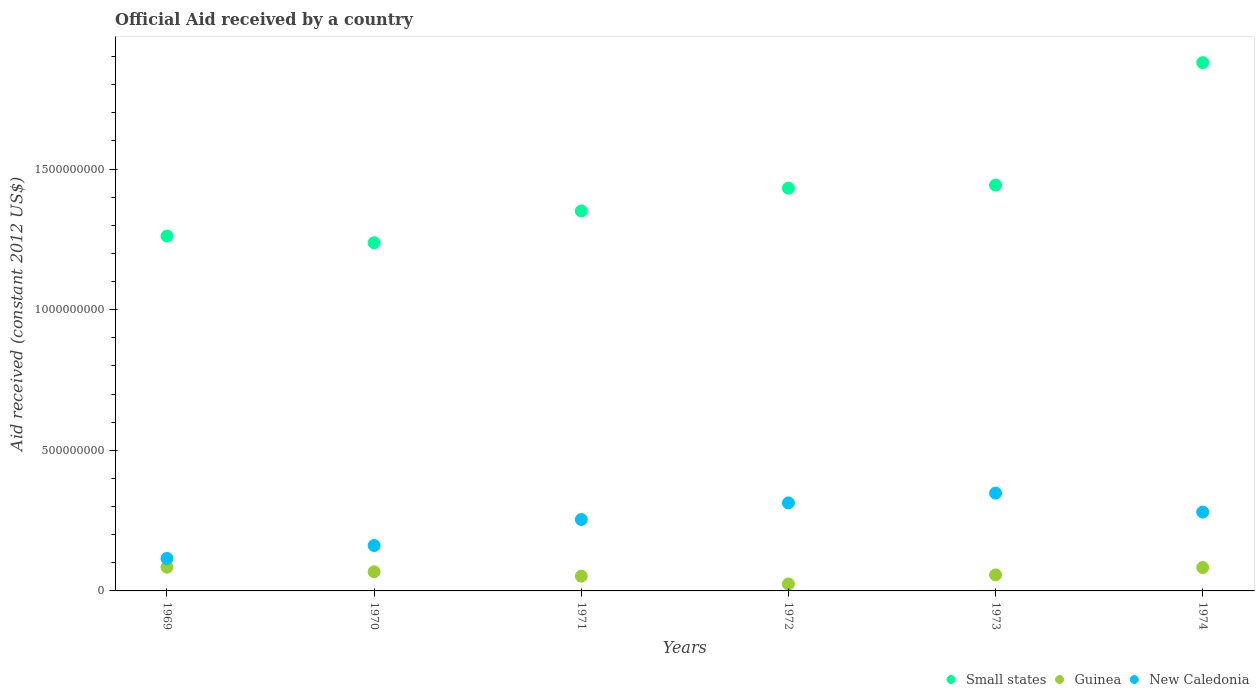What is the net official aid received in Guinea in 1969?
Provide a succinct answer. 8.44e+07. Across all years, what is the maximum net official aid received in Guinea?
Make the answer very short. 8.44e+07. Across all years, what is the minimum net official aid received in Small states?
Offer a very short reply. 1.24e+09. In which year was the net official aid received in Small states maximum?
Give a very brief answer. 1974. In which year was the net official aid received in Guinea minimum?
Your response must be concise. 1972. What is the total net official aid received in Guinea in the graph?
Provide a succinct answer. 3.70e+08. What is the difference between the net official aid received in New Caledonia in 1971 and that in 1973?
Provide a succinct answer. -9.39e+07. What is the difference between the net official aid received in Guinea in 1969 and the net official aid received in Small states in 1971?
Ensure brevity in your answer.  -1.27e+09. What is the average net official aid received in Guinea per year?
Make the answer very short. 6.16e+07. In the year 1972, what is the difference between the net official aid received in Guinea and net official aid received in New Caledonia?
Keep it short and to the point. -2.88e+08. What is the ratio of the net official aid received in New Caledonia in 1972 to that in 1973?
Give a very brief answer. 0.9. Is the net official aid received in Small states in 1970 less than that in 1972?
Make the answer very short. Yes. Is the difference between the net official aid received in Guinea in 1969 and 1973 greater than the difference between the net official aid received in New Caledonia in 1969 and 1973?
Your answer should be compact. Yes. What is the difference between the highest and the second highest net official aid received in Small states?
Offer a very short reply. 4.35e+08. What is the difference between the highest and the lowest net official aid received in Small states?
Provide a short and direct response. 6.40e+08. In how many years, is the net official aid received in Small states greater than the average net official aid received in Small states taken over all years?
Your answer should be compact. 2. Is the sum of the net official aid received in Guinea in 1970 and 1972 greater than the maximum net official aid received in Small states across all years?
Offer a very short reply. No. Is it the case that in every year, the sum of the net official aid received in Guinea and net official aid received in New Caledonia  is greater than the net official aid received in Small states?
Your response must be concise. No. Is the net official aid received in New Caledonia strictly less than the net official aid received in Small states over the years?
Your answer should be very brief. Yes. How many dotlines are there?
Ensure brevity in your answer.  3. How many years are there in the graph?
Your answer should be compact. 6. Does the graph contain any zero values?
Provide a succinct answer. No. What is the title of the graph?
Provide a succinct answer. Official Aid received by a country. What is the label or title of the X-axis?
Provide a short and direct response. Years. What is the label or title of the Y-axis?
Give a very brief answer. Aid received (constant 2012 US$). What is the Aid received (constant 2012 US$) of Small states in 1969?
Offer a very short reply. 1.26e+09. What is the Aid received (constant 2012 US$) in Guinea in 1969?
Your answer should be very brief. 8.44e+07. What is the Aid received (constant 2012 US$) in New Caledonia in 1969?
Your response must be concise. 1.15e+08. What is the Aid received (constant 2012 US$) in Small states in 1970?
Ensure brevity in your answer.  1.24e+09. What is the Aid received (constant 2012 US$) in Guinea in 1970?
Offer a terse response. 6.80e+07. What is the Aid received (constant 2012 US$) in New Caledonia in 1970?
Offer a very short reply. 1.61e+08. What is the Aid received (constant 2012 US$) of Small states in 1971?
Your response must be concise. 1.35e+09. What is the Aid received (constant 2012 US$) in Guinea in 1971?
Your answer should be very brief. 5.26e+07. What is the Aid received (constant 2012 US$) of New Caledonia in 1971?
Provide a succinct answer. 2.54e+08. What is the Aid received (constant 2012 US$) of Small states in 1972?
Ensure brevity in your answer.  1.43e+09. What is the Aid received (constant 2012 US$) in Guinea in 1972?
Your answer should be very brief. 2.47e+07. What is the Aid received (constant 2012 US$) in New Caledonia in 1972?
Ensure brevity in your answer.  3.13e+08. What is the Aid received (constant 2012 US$) in Small states in 1973?
Your answer should be very brief. 1.44e+09. What is the Aid received (constant 2012 US$) of Guinea in 1973?
Offer a terse response. 5.69e+07. What is the Aid received (constant 2012 US$) of New Caledonia in 1973?
Your answer should be very brief. 3.48e+08. What is the Aid received (constant 2012 US$) in Small states in 1974?
Your answer should be very brief. 1.88e+09. What is the Aid received (constant 2012 US$) in Guinea in 1974?
Make the answer very short. 8.30e+07. What is the Aid received (constant 2012 US$) in New Caledonia in 1974?
Your answer should be compact. 2.80e+08. Across all years, what is the maximum Aid received (constant 2012 US$) in Small states?
Your response must be concise. 1.88e+09. Across all years, what is the maximum Aid received (constant 2012 US$) in Guinea?
Make the answer very short. 8.44e+07. Across all years, what is the maximum Aid received (constant 2012 US$) of New Caledonia?
Give a very brief answer. 3.48e+08. Across all years, what is the minimum Aid received (constant 2012 US$) of Small states?
Make the answer very short. 1.24e+09. Across all years, what is the minimum Aid received (constant 2012 US$) of Guinea?
Keep it short and to the point. 2.47e+07. Across all years, what is the minimum Aid received (constant 2012 US$) of New Caledonia?
Your answer should be very brief. 1.15e+08. What is the total Aid received (constant 2012 US$) in Small states in the graph?
Your response must be concise. 8.60e+09. What is the total Aid received (constant 2012 US$) of Guinea in the graph?
Your answer should be compact. 3.70e+08. What is the total Aid received (constant 2012 US$) in New Caledonia in the graph?
Offer a terse response. 1.47e+09. What is the difference between the Aid received (constant 2012 US$) in Small states in 1969 and that in 1970?
Ensure brevity in your answer.  2.37e+07. What is the difference between the Aid received (constant 2012 US$) of Guinea in 1969 and that in 1970?
Keep it short and to the point. 1.64e+07. What is the difference between the Aid received (constant 2012 US$) in New Caledonia in 1969 and that in 1970?
Offer a terse response. -4.61e+07. What is the difference between the Aid received (constant 2012 US$) in Small states in 1969 and that in 1971?
Your answer should be compact. -8.92e+07. What is the difference between the Aid received (constant 2012 US$) of Guinea in 1969 and that in 1971?
Provide a short and direct response. 3.18e+07. What is the difference between the Aid received (constant 2012 US$) of New Caledonia in 1969 and that in 1971?
Offer a very short reply. -1.38e+08. What is the difference between the Aid received (constant 2012 US$) of Small states in 1969 and that in 1972?
Your answer should be very brief. -1.70e+08. What is the difference between the Aid received (constant 2012 US$) of Guinea in 1969 and that in 1972?
Ensure brevity in your answer.  5.97e+07. What is the difference between the Aid received (constant 2012 US$) of New Caledonia in 1969 and that in 1972?
Your answer should be very brief. -1.98e+08. What is the difference between the Aid received (constant 2012 US$) of Small states in 1969 and that in 1973?
Make the answer very short. -1.81e+08. What is the difference between the Aid received (constant 2012 US$) of Guinea in 1969 and that in 1973?
Keep it short and to the point. 2.75e+07. What is the difference between the Aid received (constant 2012 US$) in New Caledonia in 1969 and that in 1973?
Provide a succinct answer. -2.32e+08. What is the difference between the Aid received (constant 2012 US$) of Small states in 1969 and that in 1974?
Provide a short and direct response. -6.17e+08. What is the difference between the Aid received (constant 2012 US$) in Guinea in 1969 and that in 1974?
Make the answer very short. 1.37e+06. What is the difference between the Aid received (constant 2012 US$) of New Caledonia in 1969 and that in 1974?
Your answer should be compact. -1.65e+08. What is the difference between the Aid received (constant 2012 US$) of Small states in 1970 and that in 1971?
Provide a short and direct response. -1.13e+08. What is the difference between the Aid received (constant 2012 US$) in Guinea in 1970 and that in 1971?
Make the answer very short. 1.54e+07. What is the difference between the Aid received (constant 2012 US$) of New Caledonia in 1970 and that in 1971?
Ensure brevity in your answer.  -9.24e+07. What is the difference between the Aid received (constant 2012 US$) of Small states in 1970 and that in 1972?
Offer a terse response. -1.94e+08. What is the difference between the Aid received (constant 2012 US$) of Guinea in 1970 and that in 1972?
Keep it short and to the point. 4.33e+07. What is the difference between the Aid received (constant 2012 US$) of New Caledonia in 1970 and that in 1972?
Offer a terse response. -1.52e+08. What is the difference between the Aid received (constant 2012 US$) in Small states in 1970 and that in 1973?
Make the answer very short. -2.05e+08. What is the difference between the Aid received (constant 2012 US$) of Guinea in 1970 and that in 1973?
Your answer should be very brief. 1.11e+07. What is the difference between the Aid received (constant 2012 US$) in New Caledonia in 1970 and that in 1973?
Make the answer very short. -1.86e+08. What is the difference between the Aid received (constant 2012 US$) of Small states in 1970 and that in 1974?
Your answer should be very brief. -6.40e+08. What is the difference between the Aid received (constant 2012 US$) in Guinea in 1970 and that in 1974?
Offer a terse response. -1.50e+07. What is the difference between the Aid received (constant 2012 US$) of New Caledonia in 1970 and that in 1974?
Make the answer very short. -1.19e+08. What is the difference between the Aid received (constant 2012 US$) of Small states in 1971 and that in 1972?
Your answer should be very brief. -8.12e+07. What is the difference between the Aid received (constant 2012 US$) in Guinea in 1971 and that in 1972?
Offer a terse response. 2.79e+07. What is the difference between the Aid received (constant 2012 US$) of New Caledonia in 1971 and that in 1972?
Make the answer very short. -5.91e+07. What is the difference between the Aid received (constant 2012 US$) of Small states in 1971 and that in 1973?
Your response must be concise. -9.20e+07. What is the difference between the Aid received (constant 2012 US$) in Guinea in 1971 and that in 1973?
Keep it short and to the point. -4.32e+06. What is the difference between the Aid received (constant 2012 US$) in New Caledonia in 1971 and that in 1973?
Offer a terse response. -9.39e+07. What is the difference between the Aid received (constant 2012 US$) of Small states in 1971 and that in 1974?
Offer a terse response. -5.27e+08. What is the difference between the Aid received (constant 2012 US$) of Guinea in 1971 and that in 1974?
Your response must be concise. -3.05e+07. What is the difference between the Aid received (constant 2012 US$) of New Caledonia in 1971 and that in 1974?
Provide a short and direct response. -2.65e+07. What is the difference between the Aid received (constant 2012 US$) in Small states in 1972 and that in 1973?
Make the answer very short. -1.08e+07. What is the difference between the Aid received (constant 2012 US$) in Guinea in 1972 and that in 1973?
Provide a succinct answer. -3.22e+07. What is the difference between the Aid received (constant 2012 US$) of New Caledonia in 1972 and that in 1973?
Provide a short and direct response. -3.47e+07. What is the difference between the Aid received (constant 2012 US$) of Small states in 1972 and that in 1974?
Your response must be concise. -4.46e+08. What is the difference between the Aid received (constant 2012 US$) in Guinea in 1972 and that in 1974?
Offer a terse response. -5.83e+07. What is the difference between the Aid received (constant 2012 US$) of New Caledonia in 1972 and that in 1974?
Give a very brief answer. 3.26e+07. What is the difference between the Aid received (constant 2012 US$) of Small states in 1973 and that in 1974?
Provide a short and direct response. -4.35e+08. What is the difference between the Aid received (constant 2012 US$) of Guinea in 1973 and that in 1974?
Make the answer very short. -2.61e+07. What is the difference between the Aid received (constant 2012 US$) of New Caledonia in 1973 and that in 1974?
Your answer should be compact. 6.73e+07. What is the difference between the Aid received (constant 2012 US$) of Small states in 1969 and the Aid received (constant 2012 US$) of Guinea in 1970?
Your response must be concise. 1.19e+09. What is the difference between the Aid received (constant 2012 US$) of Small states in 1969 and the Aid received (constant 2012 US$) of New Caledonia in 1970?
Give a very brief answer. 1.10e+09. What is the difference between the Aid received (constant 2012 US$) of Guinea in 1969 and the Aid received (constant 2012 US$) of New Caledonia in 1970?
Provide a short and direct response. -7.70e+07. What is the difference between the Aid received (constant 2012 US$) in Small states in 1969 and the Aid received (constant 2012 US$) in Guinea in 1971?
Your answer should be very brief. 1.21e+09. What is the difference between the Aid received (constant 2012 US$) in Small states in 1969 and the Aid received (constant 2012 US$) in New Caledonia in 1971?
Offer a terse response. 1.01e+09. What is the difference between the Aid received (constant 2012 US$) of Guinea in 1969 and the Aid received (constant 2012 US$) of New Caledonia in 1971?
Ensure brevity in your answer.  -1.69e+08. What is the difference between the Aid received (constant 2012 US$) of Small states in 1969 and the Aid received (constant 2012 US$) of Guinea in 1972?
Offer a very short reply. 1.24e+09. What is the difference between the Aid received (constant 2012 US$) of Small states in 1969 and the Aid received (constant 2012 US$) of New Caledonia in 1972?
Your answer should be very brief. 9.48e+08. What is the difference between the Aid received (constant 2012 US$) in Guinea in 1969 and the Aid received (constant 2012 US$) in New Caledonia in 1972?
Ensure brevity in your answer.  -2.29e+08. What is the difference between the Aid received (constant 2012 US$) of Small states in 1969 and the Aid received (constant 2012 US$) of Guinea in 1973?
Keep it short and to the point. 1.20e+09. What is the difference between the Aid received (constant 2012 US$) of Small states in 1969 and the Aid received (constant 2012 US$) of New Caledonia in 1973?
Your response must be concise. 9.14e+08. What is the difference between the Aid received (constant 2012 US$) of Guinea in 1969 and the Aid received (constant 2012 US$) of New Caledonia in 1973?
Give a very brief answer. -2.63e+08. What is the difference between the Aid received (constant 2012 US$) in Small states in 1969 and the Aid received (constant 2012 US$) in Guinea in 1974?
Give a very brief answer. 1.18e+09. What is the difference between the Aid received (constant 2012 US$) of Small states in 1969 and the Aid received (constant 2012 US$) of New Caledonia in 1974?
Give a very brief answer. 9.81e+08. What is the difference between the Aid received (constant 2012 US$) of Guinea in 1969 and the Aid received (constant 2012 US$) of New Caledonia in 1974?
Keep it short and to the point. -1.96e+08. What is the difference between the Aid received (constant 2012 US$) of Small states in 1970 and the Aid received (constant 2012 US$) of Guinea in 1971?
Your answer should be very brief. 1.19e+09. What is the difference between the Aid received (constant 2012 US$) in Small states in 1970 and the Aid received (constant 2012 US$) in New Caledonia in 1971?
Make the answer very short. 9.84e+08. What is the difference between the Aid received (constant 2012 US$) in Guinea in 1970 and the Aid received (constant 2012 US$) in New Caledonia in 1971?
Provide a short and direct response. -1.86e+08. What is the difference between the Aid received (constant 2012 US$) in Small states in 1970 and the Aid received (constant 2012 US$) in Guinea in 1972?
Give a very brief answer. 1.21e+09. What is the difference between the Aid received (constant 2012 US$) of Small states in 1970 and the Aid received (constant 2012 US$) of New Caledonia in 1972?
Ensure brevity in your answer.  9.25e+08. What is the difference between the Aid received (constant 2012 US$) of Guinea in 1970 and the Aid received (constant 2012 US$) of New Caledonia in 1972?
Give a very brief answer. -2.45e+08. What is the difference between the Aid received (constant 2012 US$) of Small states in 1970 and the Aid received (constant 2012 US$) of Guinea in 1973?
Make the answer very short. 1.18e+09. What is the difference between the Aid received (constant 2012 US$) in Small states in 1970 and the Aid received (constant 2012 US$) in New Caledonia in 1973?
Your response must be concise. 8.90e+08. What is the difference between the Aid received (constant 2012 US$) in Guinea in 1970 and the Aid received (constant 2012 US$) in New Caledonia in 1973?
Give a very brief answer. -2.80e+08. What is the difference between the Aid received (constant 2012 US$) in Small states in 1970 and the Aid received (constant 2012 US$) in Guinea in 1974?
Give a very brief answer. 1.15e+09. What is the difference between the Aid received (constant 2012 US$) of Small states in 1970 and the Aid received (constant 2012 US$) of New Caledonia in 1974?
Your answer should be compact. 9.57e+08. What is the difference between the Aid received (constant 2012 US$) of Guinea in 1970 and the Aid received (constant 2012 US$) of New Caledonia in 1974?
Provide a succinct answer. -2.12e+08. What is the difference between the Aid received (constant 2012 US$) of Small states in 1971 and the Aid received (constant 2012 US$) of Guinea in 1972?
Your answer should be compact. 1.33e+09. What is the difference between the Aid received (constant 2012 US$) in Small states in 1971 and the Aid received (constant 2012 US$) in New Caledonia in 1972?
Keep it short and to the point. 1.04e+09. What is the difference between the Aid received (constant 2012 US$) of Guinea in 1971 and the Aid received (constant 2012 US$) of New Caledonia in 1972?
Offer a very short reply. -2.60e+08. What is the difference between the Aid received (constant 2012 US$) of Small states in 1971 and the Aid received (constant 2012 US$) of Guinea in 1973?
Ensure brevity in your answer.  1.29e+09. What is the difference between the Aid received (constant 2012 US$) in Small states in 1971 and the Aid received (constant 2012 US$) in New Caledonia in 1973?
Offer a terse response. 1.00e+09. What is the difference between the Aid received (constant 2012 US$) of Guinea in 1971 and the Aid received (constant 2012 US$) of New Caledonia in 1973?
Offer a very short reply. -2.95e+08. What is the difference between the Aid received (constant 2012 US$) in Small states in 1971 and the Aid received (constant 2012 US$) in Guinea in 1974?
Give a very brief answer. 1.27e+09. What is the difference between the Aid received (constant 2012 US$) of Small states in 1971 and the Aid received (constant 2012 US$) of New Caledonia in 1974?
Ensure brevity in your answer.  1.07e+09. What is the difference between the Aid received (constant 2012 US$) of Guinea in 1971 and the Aid received (constant 2012 US$) of New Caledonia in 1974?
Your answer should be very brief. -2.28e+08. What is the difference between the Aid received (constant 2012 US$) of Small states in 1972 and the Aid received (constant 2012 US$) of Guinea in 1973?
Give a very brief answer. 1.37e+09. What is the difference between the Aid received (constant 2012 US$) in Small states in 1972 and the Aid received (constant 2012 US$) in New Caledonia in 1973?
Your response must be concise. 1.08e+09. What is the difference between the Aid received (constant 2012 US$) in Guinea in 1972 and the Aid received (constant 2012 US$) in New Caledonia in 1973?
Offer a terse response. -3.23e+08. What is the difference between the Aid received (constant 2012 US$) in Small states in 1972 and the Aid received (constant 2012 US$) in Guinea in 1974?
Give a very brief answer. 1.35e+09. What is the difference between the Aid received (constant 2012 US$) in Small states in 1972 and the Aid received (constant 2012 US$) in New Caledonia in 1974?
Offer a very short reply. 1.15e+09. What is the difference between the Aid received (constant 2012 US$) of Guinea in 1972 and the Aid received (constant 2012 US$) of New Caledonia in 1974?
Your answer should be very brief. -2.56e+08. What is the difference between the Aid received (constant 2012 US$) of Small states in 1973 and the Aid received (constant 2012 US$) of Guinea in 1974?
Offer a very short reply. 1.36e+09. What is the difference between the Aid received (constant 2012 US$) of Small states in 1973 and the Aid received (constant 2012 US$) of New Caledonia in 1974?
Give a very brief answer. 1.16e+09. What is the difference between the Aid received (constant 2012 US$) of Guinea in 1973 and the Aid received (constant 2012 US$) of New Caledonia in 1974?
Make the answer very short. -2.24e+08. What is the average Aid received (constant 2012 US$) in Small states per year?
Give a very brief answer. 1.43e+09. What is the average Aid received (constant 2012 US$) in Guinea per year?
Offer a terse response. 6.16e+07. What is the average Aid received (constant 2012 US$) of New Caledonia per year?
Provide a short and direct response. 2.45e+08. In the year 1969, what is the difference between the Aid received (constant 2012 US$) in Small states and Aid received (constant 2012 US$) in Guinea?
Offer a very short reply. 1.18e+09. In the year 1969, what is the difference between the Aid received (constant 2012 US$) in Small states and Aid received (constant 2012 US$) in New Caledonia?
Give a very brief answer. 1.15e+09. In the year 1969, what is the difference between the Aid received (constant 2012 US$) in Guinea and Aid received (constant 2012 US$) in New Caledonia?
Your answer should be very brief. -3.10e+07. In the year 1970, what is the difference between the Aid received (constant 2012 US$) of Small states and Aid received (constant 2012 US$) of Guinea?
Keep it short and to the point. 1.17e+09. In the year 1970, what is the difference between the Aid received (constant 2012 US$) of Small states and Aid received (constant 2012 US$) of New Caledonia?
Offer a very short reply. 1.08e+09. In the year 1970, what is the difference between the Aid received (constant 2012 US$) in Guinea and Aid received (constant 2012 US$) in New Caledonia?
Ensure brevity in your answer.  -9.35e+07. In the year 1971, what is the difference between the Aid received (constant 2012 US$) of Small states and Aid received (constant 2012 US$) of Guinea?
Make the answer very short. 1.30e+09. In the year 1971, what is the difference between the Aid received (constant 2012 US$) in Small states and Aid received (constant 2012 US$) in New Caledonia?
Your answer should be very brief. 1.10e+09. In the year 1971, what is the difference between the Aid received (constant 2012 US$) of Guinea and Aid received (constant 2012 US$) of New Caledonia?
Make the answer very short. -2.01e+08. In the year 1972, what is the difference between the Aid received (constant 2012 US$) of Small states and Aid received (constant 2012 US$) of Guinea?
Your answer should be very brief. 1.41e+09. In the year 1972, what is the difference between the Aid received (constant 2012 US$) of Small states and Aid received (constant 2012 US$) of New Caledonia?
Provide a short and direct response. 1.12e+09. In the year 1972, what is the difference between the Aid received (constant 2012 US$) in Guinea and Aid received (constant 2012 US$) in New Caledonia?
Keep it short and to the point. -2.88e+08. In the year 1973, what is the difference between the Aid received (constant 2012 US$) in Small states and Aid received (constant 2012 US$) in Guinea?
Offer a terse response. 1.39e+09. In the year 1973, what is the difference between the Aid received (constant 2012 US$) of Small states and Aid received (constant 2012 US$) of New Caledonia?
Ensure brevity in your answer.  1.09e+09. In the year 1973, what is the difference between the Aid received (constant 2012 US$) of Guinea and Aid received (constant 2012 US$) of New Caledonia?
Provide a succinct answer. -2.91e+08. In the year 1974, what is the difference between the Aid received (constant 2012 US$) in Small states and Aid received (constant 2012 US$) in Guinea?
Provide a succinct answer. 1.80e+09. In the year 1974, what is the difference between the Aid received (constant 2012 US$) in Small states and Aid received (constant 2012 US$) in New Caledonia?
Make the answer very short. 1.60e+09. In the year 1974, what is the difference between the Aid received (constant 2012 US$) in Guinea and Aid received (constant 2012 US$) in New Caledonia?
Make the answer very short. -1.97e+08. What is the ratio of the Aid received (constant 2012 US$) of Small states in 1969 to that in 1970?
Keep it short and to the point. 1.02. What is the ratio of the Aid received (constant 2012 US$) in Guinea in 1969 to that in 1970?
Your answer should be very brief. 1.24. What is the ratio of the Aid received (constant 2012 US$) in New Caledonia in 1969 to that in 1970?
Ensure brevity in your answer.  0.71. What is the ratio of the Aid received (constant 2012 US$) in Small states in 1969 to that in 1971?
Your answer should be very brief. 0.93. What is the ratio of the Aid received (constant 2012 US$) in Guinea in 1969 to that in 1971?
Keep it short and to the point. 1.61. What is the ratio of the Aid received (constant 2012 US$) in New Caledonia in 1969 to that in 1971?
Your answer should be very brief. 0.45. What is the ratio of the Aid received (constant 2012 US$) of Small states in 1969 to that in 1972?
Offer a terse response. 0.88. What is the ratio of the Aid received (constant 2012 US$) in Guinea in 1969 to that in 1972?
Keep it short and to the point. 3.42. What is the ratio of the Aid received (constant 2012 US$) in New Caledonia in 1969 to that in 1972?
Provide a succinct answer. 0.37. What is the ratio of the Aid received (constant 2012 US$) of Small states in 1969 to that in 1973?
Offer a terse response. 0.87. What is the ratio of the Aid received (constant 2012 US$) in Guinea in 1969 to that in 1973?
Offer a very short reply. 1.48. What is the ratio of the Aid received (constant 2012 US$) of New Caledonia in 1969 to that in 1973?
Provide a succinct answer. 0.33. What is the ratio of the Aid received (constant 2012 US$) of Small states in 1969 to that in 1974?
Your response must be concise. 0.67. What is the ratio of the Aid received (constant 2012 US$) of Guinea in 1969 to that in 1974?
Keep it short and to the point. 1.02. What is the ratio of the Aid received (constant 2012 US$) of New Caledonia in 1969 to that in 1974?
Make the answer very short. 0.41. What is the ratio of the Aid received (constant 2012 US$) of Small states in 1970 to that in 1971?
Your answer should be very brief. 0.92. What is the ratio of the Aid received (constant 2012 US$) in Guinea in 1970 to that in 1971?
Provide a short and direct response. 1.29. What is the ratio of the Aid received (constant 2012 US$) in New Caledonia in 1970 to that in 1971?
Provide a succinct answer. 0.64. What is the ratio of the Aid received (constant 2012 US$) in Small states in 1970 to that in 1972?
Make the answer very short. 0.86. What is the ratio of the Aid received (constant 2012 US$) of Guinea in 1970 to that in 1972?
Provide a short and direct response. 2.75. What is the ratio of the Aid received (constant 2012 US$) in New Caledonia in 1970 to that in 1972?
Provide a short and direct response. 0.52. What is the ratio of the Aid received (constant 2012 US$) of Small states in 1970 to that in 1973?
Offer a very short reply. 0.86. What is the ratio of the Aid received (constant 2012 US$) of Guinea in 1970 to that in 1973?
Provide a succinct answer. 1.2. What is the ratio of the Aid received (constant 2012 US$) of New Caledonia in 1970 to that in 1973?
Your response must be concise. 0.46. What is the ratio of the Aid received (constant 2012 US$) of Small states in 1970 to that in 1974?
Offer a terse response. 0.66. What is the ratio of the Aid received (constant 2012 US$) in Guinea in 1970 to that in 1974?
Ensure brevity in your answer.  0.82. What is the ratio of the Aid received (constant 2012 US$) of New Caledonia in 1970 to that in 1974?
Offer a terse response. 0.58. What is the ratio of the Aid received (constant 2012 US$) of Small states in 1971 to that in 1972?
Your response must be concise. 0.94. What is the ratio of the Aid received (constant 2012 US$) of Guinea in 1971 to that in 1972?
Keep it short and to the point. 2.13. What is the ratio of the Aid received (constant 2012 US$) of New Caledonia in 1971 to that in 1972?
Make the answer very short. 0.81. What is the ratio of the Aid received (constant 2012 US$) in Small states in 1971 to that in 1973?
Your answer should be compact. 0.94. What is the ratio of the Aid received (constant 2012 US$) of Guinea in 1971 to that in 1973?
Give a very brief answer. 0.92. What is the ratio of the Aid received (constant 2012 US$) in New Caledonia in 1971 to that in 1973?
Offer a very short reply. 0.73. What is the ratio of the Aid received (constant 2012 US$) of Small states in 1971 to that in 1974?
Make the answer very short. 0.72. What is the ratio of the Aid received (constant 2012 US$) of Guinea in 1971 to that in 1974?
Your answer should be very brief. 0.63. What is the ratio of the Aid received (constant 2012 US$) in New Caledonia in 1971 to that in 1974?
Your answer should be very brief. 0.91. What is the ratio of the Aid received (constant 2012 US$) in Guinea in 1972 to that in 1973?
Your answer should be very brief. 0.43. What is the ratio of the Aid received (constant 2012 US$) of New Caledonia in 1972 to that in 1973?
Offer a very short reply. 0.9. What is the ratio of the Aid received (constant 2012 US$) of Small states in 1972 to that in 1974?
Keep it short and to the point. 0.76. What is the ratio of the Aid received (constant 2012 US$) of Guinea in 1972 to that in 1974?
Your response must be concise. 0.3. What is the ratio of the Aid received (constant 2012 US$) of New Caledonia in 1972 to that in 1974?
Your answer should be compact. 1.12. What is the ratio of the Aid received (constant 2012 US$) in Small states in 1973 to that in 1974?
Keep it short and to the point. 0.77. What is the ratio of the Aid received (constant 2012 US$) of Guinea in 1973 to that in 1974?
Give a very brief answer. 0.69. What is the ratio of the Aid received (constant 2012 US$) of New Caledonia in 1973 to that in 1974?
Your response must be concise. 1.24. What is the difference between the highest and the second highest Aid received (constant 2012 US$) of Small states?
Offer a terse response. 4.35e+08. What is the difference between the highest and the second highest Aid received (constant 2012 US$) in Guinea?
Offer a very short reply. 1.37e+06. What is the difference between the highest and the second highest Aid received (constant 2012 US$) of New Caledonia?
Offer a very short reply. 3.47e+07. What is the difference between the highest and the lowest Aid received (constant 2012 US$) in Small states?
Make the answer very short. 6.40e+08. What is the difference between the highest and the lowest Aid received (constant 2012 US$) of Guinea?
Give a very brief answer. 5.97e+07. What is the difference between the highest and the lowest Aid received (constant 2012 US$) in New Caledonia?
Your response must be concise. 2.32e+08. 